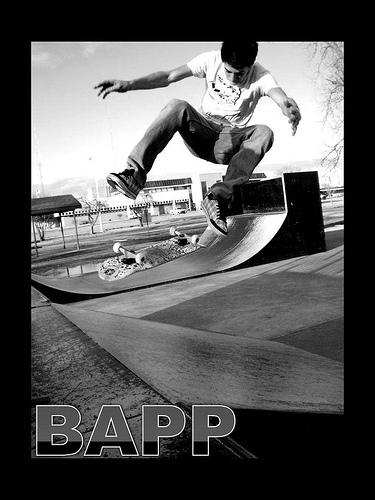World skate is the head controller of which sport?

Choices:
A) surfing
B) swimming
C) skiing
D) skating skating 